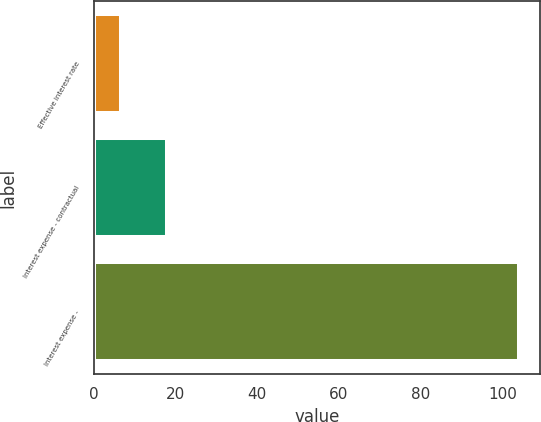Convert chart to OTSL. <chart><loc_0><loc_0><loc_500><loc_500><bar_chart><fcel>Effective interest rate<fcel>Interest expense - contractual<fcel>Interest expense -<nl><fcel>6.78<fcel>18<fcel>104<nl></chart> 